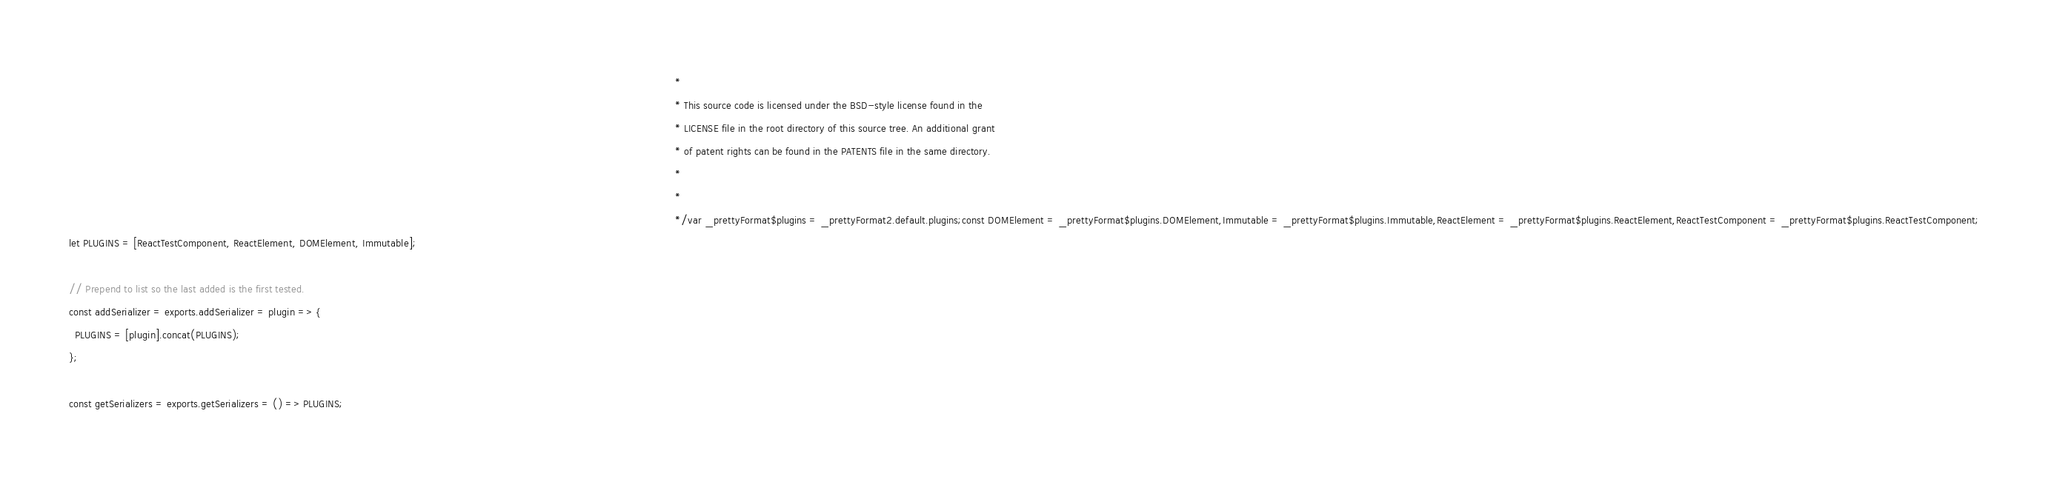<code> <loc_0><loc_0><loc_500><loc_500><_JavaScript_>                                                                                                                                                                                                       *
                                                                                                                                                                                                       * This source code is licensed under the BSD-style license found in the
                                                                                                                                                                                                       * LICENSE file in the root directory of this source tree. An additional grant
                                                                                                                                                                                                       * of patent rights can be found in the PATENTS file in the same directory.
                                                                                                                                                                                                       *
                                                                                                                                                                                                       * 
                                                                                                                                                                                                       */var _prettyFormat$plugins = _prettyFormat2.default.plugins;const DOMElement = _prettyFormat$plugins.DOMElement,Immutable = _prettyFormat$plugins.Immutable,ReactElement = _prettyFormat$plugins.ReactElement,ReactTestComponent = _prettyFormat$plugins.ReactTestComponent;
let PLUGINS = [ReactTestComponent, ReactElement, DOMElement, Immutable];

// Prepend to list so the last added is the first tested.
const addSerializer = exports.addSerializer = plugin => {
  PLUGINS = [plugin].concat(PLUGINS);
};

const getSerializers = exports.getSerializers = () => PLUGINS;</code> 